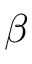<formula> <loc_0><loc_0><loc_500><loc_500>\beta</formula> 